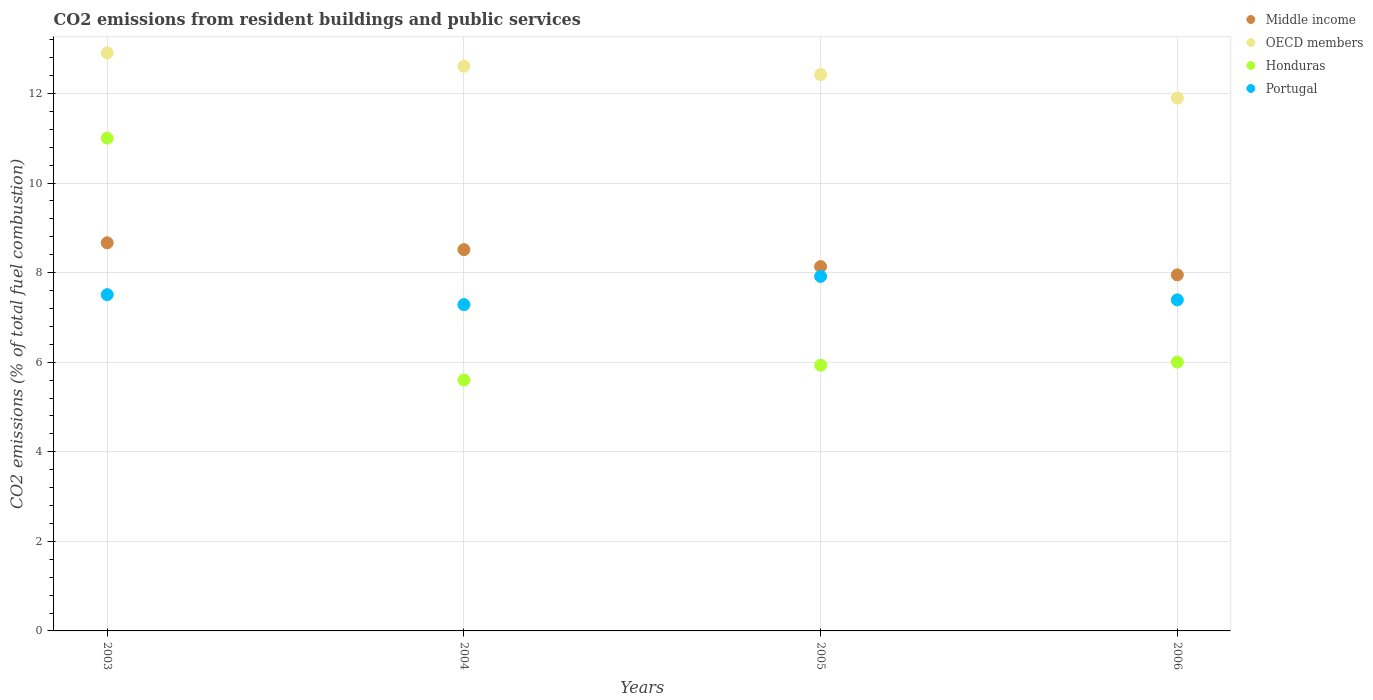How many different coloured dotlines are there?
Give a very brief answer. 4. What is the total CO2 emitted in OECD members in 2005?
Keep it short and to the point. 12.42. Across all years, what is the maximum total CO2 emitted in OECD members?
Provide a succinct answer. 12.91. Across all years, what is the minimum total CO2 emitted in Middle income?
Provide a short and direct response. 7.95. In which year was the total CO2 emitted in Honduras minimum?
Ensure brevity in your answer.  2004. What is the total total CO2 emitted in Portugal in the graph?
Offer a very short reply. 30.1. What is the difference between the total CO2 emitted in Portugal in 2003 and that in 2004?
Give a very brief answer. 0.22. What is the difference between the total CO2 emitted in Middle income in 2004 and the total CO2 emitted in OECD members in 2005?
Make the answer very short. -3.91. What is the average total CO2 emitted in Honduras per year?
Offer a terse response. 7.14. In the year 2005, what is the difference between the total CO2 emitted in Portugal and total CO2 emitted in Honduras?
Offer a very short reply. 1.98. What is the ratio of the total CO2 emitted in Middle income in 2003 to that in 2004?
Keep it short and to the point. 1.02. What is the difference between the highest and the second highest total CO2 emitted in Honduras?
Your answer should be compact. 5. What is the difference between the highest and the lowest total CO2 emitted in OECD members?
Keep it short and to the point. 1.01. In how many years, is the total CO2 emitted in Portugal greater than the average total CO2 emitted in Portugal taken over all years?
Provide a short and direct response. 1. Is it the case that in every year, the sum of the total CO2 emitted in Honduras and total CO2 emitted in OECD members  is greater than the sum of total CO2 emitted in Portugal and total CO2 emitted in Middle income?
Your answer should be very brief. Yes. Is the total CO2 emitted in Middle income strictly less than the total CO2 emitted in Honduras over the years?
Offer a very short reply. No. How many years are there in the graph?
Offer a very short reply. 4. Are the values on the major ticks of Y-axis written in scientific E-notation?
Your response must be concise. No. Does the graph contain grids?
Make the answer very short. Yes. How many legend labels are there?
Ensure brevity in your answer.  4. How are the legend labels stacked?
Your answer should be very brief. Vertical. What is the title of the graph?
Provide a short and direct response. CO2 emissions from resident buildings and public services. What is the label or title of the Y-axis?
Ensure brevity in your answer.  CO2 emissions (% of total fuel combustion). What is the CO2 emissions (% of total fuel combustion) of Middle income in 2003?
Ensure brevity in your answer.  8.67. What is the CO2 emissions (% of total fuel combustion) in OECD members in 2003?
Make the answer very short. 12.91. What is the CO2 emissions (% of total fuel combustion) in Honduras in 2003?
Offer a very short reply. 11. What is the CO2 emissions (% of total fuel combustion) in Portugal in 2003?
Your answer should be compact. 7.51. What is the CO2 emissions (% of total fuel combustion) in Middle income in 2004?
Make the answer very short. 8.51. What is the CO2 emissions (% of total fuel combustion) of OECD members in 2004?
Make the answer very short. 12.61. What is the CO2 emissions (% of total fuel combustion) in Honduras in 2004?
Provide a short and direct response. 5.6. What is the CO2 emissions (% of total fuel combustion) of Portugal in 2004?
Your answer should be very brief. 7.29. What is the CO2 emissions (% of total fuel combustion) of Middle income in 2005?
Offer a very short reply. 8.13. What is the CO2 emissions (% of total fuel combustion) of OECD members in 2005?
Your response must be concise. 12.42. What is the CO2 emissions (% of total fuel combustion) of Honduras in 2005?
Your answer should be very brief. 5.93. What is the CO2 emissions (% of total fuel combustion) of Portugal in 2005?
Your answer should be compact. 7.92. What is the CO2 emissions (% of total fuel combustion) of Middle income in 2006?
Ensure brevity in your answer.  7.95. What is the CO2 emissions (% of total fuel combustion) of OECD members in 2006?
Your answer should be compact. 11.9. What is the CO2 emissions (% of total fuel combustion) of Honduras in 2006?
Make the answer very short. 6. What is the CO2 emissions (% of total fuel combustion) of Portugal in 2006?
Your response must be concise. 7.39. Across all years, what is the maximum CO2 emissions (% of total fuel combustion) of Middle income?
Make the answer very short. 8.67. Across all years, what is the maximum CO2 emissions (% of total fuel combustion) of OECD members?
Your response must be concise. 12.91. Across all years, what is the maximum CO2 emissions (% of total fuel combustion) in Honduras?
Give a very brief answer. 11. Across all years, what is the maximum CO2 emissions (% of total fuel combustion) in Portugal?
Provide a short and direct response. 7.92. Across all years, what is the minimum CO2 emissions (% of total fuel combustion) of Middle income?
Keep it short and to the point. 7.95. Across all years, what is the minimum CO2 emissions (% of total fuel combustion) of OECD members?
Your answer should be very brief. 11.9. Across all years, what is the minimum CO2 emissions (% of total fuel combustion) of Honduras?
Make the answer very short. 5.6. Across all years, what is the minimum CO2 emissions (% of total fuel combustion) of Portugal?
Offer a very short reply. 7.29. What is the total CO2 emissions (% of total fuel combustion) of Middle income in the graph?
Provide a succinct answer. 33.27. What is the total CO2 emissions (% of total fuel combustion) in OECD members in the graph?
Your answer should be very brief. 49.84. What is the total CO2 emissions (% of total fuel combustion) in Honduras in the graph?
Make the answer very short. 28.54. What is the total CO2 emissions (% of total fuel combustion) in Portugal in the graph?
Offer a very short reply. 30.1. What is the difference between the CO2 emissions (% of total fuel combustion) in Middle income in 2003 and that in 2004?
Provide a short and direct response. 0.15. What is the difference between the CO2 emissions (% of total fuel combustion) in OECD members in 2003 and that in 2004?
Your answer should be compact. 0.3. What is the difference between the CO2 emissions (% of total fuel combustion) in Honduras in 2003 and that in 2004?
Ensure brevity in your answer.  5.4. What is the difference between the CO2 emissions (% of total fuel combustion) in Portugal in 2003 and that in 2004?
Give a very brief answer. 0.22. What is the difference between the CO2 emissions (% of total fuel combustion) in Middle income in 2003 and that in 2005?
Provide a short and direct response. 0.53. What is the difference between the CO2 emissions (% of total fuel combustion) in OECD members in 2003 and that in 2005?
Ensure brevity in your answer.  0.48. What is the difference between the CO2 emissions (% of total fuel combustion) in Honduras in 2003 and that in 2005?
Make the answer very short. 5.07. What is the difference between the CO2 emissions (% of total fuel combustion) in Portugal in 2003 and that in 2005?
Your answer should be compact. -0.41. What is the difference between the CO2 emissions (% of total fuel combustion) in Middle income in 2003 and that in 2006?
Your answer should be compact. 0.72. What is the difference between the CO2 emissions (% of total fuel combustion) in OECD members in 2003 and that in 2006?
Your answer should be compact. 1.01. What is the difference between the CO2 emissions (% of total fuel combustion) in Honduras in 2003 and that in 2006?
Offer a terse response. 5. What is the difference between the CO2 emissions (% of total fuel combustion) of Portugal in 2003 and that in 2006?
Give a very brief answer. 0.12. What is the difference between the CO2 emissions (% of total fuel combustion) of Middle income in 2004 and that in 2005?
Provide a short and direct response. 0.38. What is the difference between the CO2 emissions (% of total fuel combustion) in OECD members in 2004 and that in 2005?
Provide a short and direct response. 0.19. What is the difference between the CO2 emissions (% of total fuel combustion) of Honduras in 2004 and that in 2005?
Your answer should be compact. -0.33. What is the difference between the CO2 emissions (% of total fuel combustion) in Portugal in 2004 and that in 2005?
Your response must be concise. -0.63. What is the difference between the CO2 emissions (% of total fuel combustion) of Middle income in 2004 and that in 2006?
Provide a succinct answer. 0.56. What is the difference between the CO2 emissions (% of total fuel combustion) of OECD members in 2004 and that in 2006?
Make the answer very short. 0.71. What is the difference between the CO2 emissions (% of total fuel combustion) of Honduras in 2004 and that in 2006?
Provide a short and direct response. -0.4. What is the difference between the CO2 emissions (% of total fuel combustion) of Portugal in 2004 and that in 2006?
Your response must be concise. -0.11. What is the difference between the CO2 emissions (% of total fuel combustion) in Middle income in 2005 and that in 2006?
Keep it short and to the point. 0.18. What is the difference between the CO2 emissions (% of total fuel combustion) in OECD members in 2005 and that in 2006?
Your answer should be very brief. 0.52. What is the difference between the CO2 emissions (% of total fuel combustion) of Honduras in 2005 and that in 2006?
Keep it short and to the point. -0.07. What is the difference between the CO2 emissions (% of total fuel combustion) of Portugal in 2005 and that in 2006?
Your answer should be very brief. 0.52. What is the difference between the CO2 emissions (% of total fuel combustion) of Middle income in 2003 and the CO2 emissions (% of total fuel combustion) of OECD members in 2004?
Keep it short and to the point. -3.94. What is the difference between the CO2 emissions (% of total fuel combustion) in Middle income in 2003 and the CO2 emissions (% of total fuel combustion) in Honduras in 2004?
Give a very brief answer. 3.06. What is the difference between the CO2 emissions (% of total fuel combustion) of Middle income in 2003 and the CO2 emissions (% of total fuel combustion) of Portugal in 2004?
Your answer should be very brief. 1.38. What is the difference between the CO2 emissions (% of total fuel combustion) of OECD members in 2003 and the CO2 emissions (% of total fuel combustion) of Honduras in 2004?
Your response must be concise. 7.3. What is the difference between the CO2 emissions (% of total fuel combustion) of OECD members in 2003 and the CO2 emissions (% of total fuel combustion) of Portugal in 2004?
Provide a succinct answer. 5.62. What is the difference between the CO2 emissions (% of total fuel combustion) of Honduras in 2003 and the CO2 emissions (% of total fuel combustion) of Portugal in 2004?
Your answer should be very brief. 3.72. What is the difference between the CO2 emissions (% of total fuel combustion) of Middle income in 2003 and the CO2 emissions (% of total fuel combustion) of OECD members in 2005?
Give a very brief answer. -3.76. What is the difference between the CO2 emissions (% of total fuel combustion) in Middle income in 2003 and the CO2 emissions (% of total fuel combustion) in Honduras in 2005?
Provide a short and direct response. 2.73. What is the difference between the CO2 emissions (% of total fuel combustion) of Middle income in 2003 and the CO2 emissions (% of total fuel combustion) of Portugal in 2005?
Provide a succinct answer. 0.75. What is the difference between the CO2 emissions (% of total fuel combustion) of OECD members in 2003 and the CO2 emissions (% of total fuel combustion) of Honduras in 2005?
Your answer should be compact. 6.97. What is the difference between the CO2 emissions (% of total fuel combustion) in OECD members in 2003 and the CO2 emissions (% of total fuel combustion) in Portugal in 2005?
Give a very brief answer. 4.99. What is the difference between the CO2 emissions (% of total fuel combustion) in Honduras in 2003 and the CO2 emissions (% of total fuel combustion) in Portugal in 2005?
Your response must be concise. 3.09. What is the difference between the CO2 emissions (% of total fuel combustion) in Middle income in 2003 and the CO2 emissions (% of total fuel combustion) in OECD members in 2006?
Offer a terse response. -3.23. What is the difference between the CO2 emissions (% of total fuel combustion) in Middle income in 2003 and the CO2 emissions (% of total fuel combustion) in Honduras in 2006?
Ensure brevity in your answer.  2.66. What is the difference between the CO2 emissions (% of total fuel combustion) in Middle income in 2003 and the CO2 emissions (% of total fuel combustion) in Portugal in 2006?
Offer a terse response. 1.27. What is the difference between the CO2 emissions (% of total fuel combustion) of OECD members in 2003 and the CO2 emissions (% of total fuel combustion) of Honduras in 2006?
Your answer should be very brief. 6.9. What is the difference between the CO2 emissions (% of total fuel combustion) in OECD members in 2003 and the CO2 emissions (% of total fuel combustion) in Portugal in 2006?
Keep it short and to the point. 5.51. What is the difference between the CO2 emissions (% of total fuel combustion) of Honduras in 2003 and the CO2 emissions (% of total fuel combustion) of Portugal in 2006?
Your response must be concise. 3.61. What is the difference between the CO2 emissions (% of total fuel combustion) in Middle income in 2004 and the CO2 emissions (% of total fuel combustion) in OECD members in 2005?
Your response must be concise. -3.91. What is the difference between the CO2 emissions (% of total fuel combustion) in Middle income in 2004 and the CO2 emissions (% of total fuel combustion) in Honduras in 2005?
Offer a very short reply. 2.58. What is the difference between the CO2 emissions (% of total fuel combustion) in Middle income in 2004 and the CO2 emissions (% of total fuel combustion) in Portugal in 2005?
Offer a very short reply. 0.6. What is the difference between the CO2 emissions (% of total fuel combustion) in OECD members in 2004 and the CO2 emissions (% of total fuel combustion) in Honduras in 2005?
Offer a very short reply. 6.68. What is the difference between the CO2 emissions (% of total fuel combustion) in OECD members in 2004 and the CO2 emissions (% of total fuel combustion) in Portugal in 2005?
Provide a short and direct response. 4.69. What is the difference between the CO2 emissions (% of total fuel combustion) in Honduras in 2004 and the CO2 emissions (% of total fuel combustion) in Portugal in 2005?
Give a very brief answer. -2.31. What is the difference between the CO2 emissions (% of total fuel combustion) in Middle income in 2004 and the CO2 emissions (% of total fuel combustion) in OECD members in 2006?
Your response must be concise. -3.38. What is the difference between the CO2 emissions (% of total fuel combustion) in Middle income in 2004 and the CO2 emissions (% of total fuel combustion) in Honduras in 2006?
Your answer should be compact. 2.51. What is the difference between the CO2 emissions (% of total fuel combustion) in Middle income in 2004 and the CO2 emissions (% of total fuel combustion) in Portugal in 2006?
Make the answer very short. 1.12. What is the difference between the CO2 emissions (% of total fuel combustion) in OECD members in 2004 and the CO2 emissions (% of total fuel combustion) in Honduras in 2006?
Give a very brief answer. 6.61. What is the difference between the CO2 emissions (% of total fuel combustion) of OECD members in 2004 and the CO2 emissions (% of total fuel combustion) of Portugal in 2006?
Make the answer very short. 5.22. What is the difference between the CO2 emissions (% of total fuel combustion) of Honduras in 2004 and the CO2 emissions (% of total fuel combustion) of Portugal in 2006?
Offer a terse response. -1.79. What is the difference between the CO2 emissions (% of total fuel combustion) of Middle income in 2005 and the CO2 emissions (% of total fuel combustion) of OECD members in 2006?
Make the answer very short. -3.76. What is the difference between the CO2 emissions (% of total fuel combustion) in Middle income in 2005 and the CO2 emissions (% of total fuel combustion) in Honduras in 2006?
Provide a succinct answer. 2.13. What is the difference between the CO2 emissions (% of total fuel combustion) in Middle income in 2005 and the CO2 emissions (% of total fuel combustion) in Portugal in 2006?
Give a very brief answer. 0.74. What is the difference between the CO2 emissions (% of total fuel combustion) of OECD members in 2005 and the CO2 emissions (% of total fuel combustion) of Honduras in 2006?
Your answer should be compact. 6.42. What is the difference between the CO2 emissions (% of total fuel combustion) in OECD members in 2005 and the CO2 emissions (% of total fuel combustion) in Portugal in 2006?
Make the answer very short. 5.03. What is the difference between the CO2 emissions (% of total fuel combustion) in Honduras in 2005 and the CO2 emissions (% of total fuel combustion) in Portugal in 2006?
Keep it short and to the point. -1.46. What is the average CO2 emissions (% of total fuel combustion) in Middle income per year?
Give a very brief answer. 8.32. What is the average CO2 emissions (% of total fuel combustion) of OECD members per year?
Your response must be concise. 12.46. What is the average CO2 emissions (% of total fuel combustion) in Honduras per year?
Offer a terse response. 7.14. What is the average CO2 emissions (% of total fuel combustion) of Portugal per year?
Ensure brevity in your answer.  7.53. In the year 2003, what is the difference between the CO2 emissions (% of total fuel combustion) of Middle income and CO2 emissions (% of total fuel combustion) of OECD members?
Offer a very short reply. -4.24. In the year 2003, what is the difference between the CO2 emissions (% of total fuel combustion) of Middle income and CO2 emissions (% of total fuel combustion) of Honduras?
Your answer should be compact. -2.34. In the year 2003, what is the difference between the CO2 emissions (% of total fuel combustion) in Middle income and CO2 emissions (% of total fuel combustion) in Portugal?
Your answer should be very brief. 1.16. In the year 2003, what is the difference between the CO2 emissions (% of total fuel combustion) in OECD members and CO2 emissions (% of total fuel combustion) in Honduras?
Offer a terse response. 1.9. In the year 2003, what is the difference between the CO2 emissions (% of total fuel combustion) of OECD members and CO2 emissions (% of total fuel combustion) of Portugal?
Offer a very short reply. 5.4. In the year 2003, what is the difference between the CO2 emissions (% of total fuel combustion) of Honduras and CO2 emissions (% of total fuel combustion) of Portugal?
Provide a succinct answer. 3.49. In the year 2004, what is the difference between the CO2 emissions (% of total fuel combustion) of Middle income and CO2 emissions (% of total fuel combustion) of OECD members?
Give a very brief answer. -4.09. In the year 2004, what is the difference between the CO2 emissions (% of total fuel combustion) in Middle income and CO2 emissions (% of total fuel combustion) in Honduras?
Give a very brief answer. 2.91. In the year 2004, what is the difference between the CO2 emissions (% of total fuel combustion) in Middle income and CO2 emissions (% of total fuel combustion) in Portugal?
Your answer should be very brief. 1.23. In the year 2004, what is the difference between the CO2 emissions (% of total fuel combustion) of OECD members and CO2 emissions (% of total fuel combustion) of Honduras?
Your response must be concise. 7.01. In the year 2004, what is the difference between the CO2 emissions (% of total fuel combustion) of OECD members and CO2 emissions (% of total fuel combustion) of Portugal?
Give a very brief answer. 5.32. In the year 2004, what is the difference between the CO2 emissions (% of total fuel combustion) of Honduras and CO2 emissions (% of total fuel combustion) of Portugal?
Your answer should be compact. -1.68. In the year 2005, what is the difference between the CO2 emissions (% of total fuel combustion) in Middle income and CO2 emissions (% of total fuel combustion) in OECD members?
Your answer should be compact. -4.29. In the year 2005, what is the difference between the CO2 emissions (% of total fuel combustion) in Middle income and CO2 emissions (% of total fuel combustion) in Honduras?
Offer a terse response. 2.2. In the year 2005, what is the difference between the CO2 emissions (% of total fuel combustion) in Middle income and CO2 emissions (% of total fuel combustion) in Portugal?
Provide a succinct answer. 0.22. In the year 2005, what is the difference between the CO2 emissions (% of total fuel combustion) of OECD members and CO2 emissions (% of total fuel combustion) of Honduras?
Offer a terse response. 6.49. In the year 2005, what is the difference between the CO2 emissions (% of total fuel combustion) of OECD members and CO2 emissions (% of total fuel combustion) of Portugal?
Provide a short and direct response. 4.51. In the year 2005, what is the difference between the CO2 emissions (% of total fuel combustion) in Honduras and CO2 emissions (% of total fuel combustion) in Portugal?
Make the answer very short. -1.98. In the year 2006, what is the difference between the CO2 emissions (% of total fuel combustion) in Middle income and CO2 emissions (% of total fuel combustion) in OECD members?
Your answer should be compact. -3.95. In the year 2006, what is the difference between the CO2 emissions (% of total fuel combustion) in Middle income and CO2 emissions (% of total fuel combustion) in Honduras?
Provide a succinct answer. 1.95. In the year 2006, what is the difference between the CO2 emissions (% of total fuel combustion) of Middle income and CO2 emissions (% of total fuel combustion) of Portugal?
Offer a very short reply. 0.56. In the year 2006, what is the difference between the CO2 emissions (% of total fuel combustion) of OECD members and CO2 emissions (% of total fuel combustion) of Honduras?
Give a very brief answer. 5.9. In the year 2006, what is the difference between the CO2 emissions (% of total fuel combustion) in OECD members and CO2 emissions (% of total fuel combustion) in Portugal?
Make the answer very short. 4.51. In the year 2006, what is the difference between the CO2 emissions (% of total fuel combustion) in Honduras and CO2 emissions (% of total fuel combustion) in Portugal?
Offer a very short reply. -1.39. What is the ratio of the CO2 emissions (% of total fuel combustion) in Middle income in 2003 to that in 2004?
Your answer should be compact. 1.02. What is the ratio of the CO2 emissions (% of total fuel combustion) in OECD members in 2003 to that in 2004?
Offer a very short reply. 1.02. What is the ratio of the CO2 emissions (% of total fuel combustion) of Honduras in 2003 to that in 2004?
Ensure brevity in your answer.  1.96. What is the ratio of the CO2 emissions (% of total fuel combustion) in Portugal in 2003 to that in 2004?
Offer a terse response. 1.03. What is the ratio of the CO2 emissions (% of total fuel combustion) of Middle income in 2003 to that in 2005?
Offer a very short reply. 1.07. What is the ratio of the CO2 emissions (% of total fuel combustion) in OECD members in 2003 to that in 2005?
Offer a very short reply. 1.04. What is the ratio of the CO2 emissions (% of total fuel combustion) in Honduras in 2003 to that in 2005?
Your answer should be compact. 1.85. What is the ratio of the CO2 emissions (% of total fuel combustion) in Portugal in 2003 to that in 2005?
Give a very brief answer. 0.95. What is the ratio of the CO2 emissions (% of total fuel combustion) of Middle income in 2003 to that in 2006?
Your answer should be compact. 1.09. What is the ratio of the CO2 emissions (% of total fuel combustion) of OECD members in 2003 to that in 2006?
Make the answer very short. 1.08. What is the ratio of the CO2 emissions (% of total fuel combustion) in Honduras in 2003 to that in 2006?
Your answer should be very brief. 1.83. What is the ratio of the CO2 emissions (% of total fuel combustion) of Portugal in 2003 to that in 2006?
Ensure brevity in your answer.  1.02. What is the ratio of the CO2 emissions (% of total fuel combustion) in Middle income in 2004 to that in 2005?
Your answer should be compact. 1.05. What is the ratio of the CO2 emissions (% of total fuel combustion) in OECD members in 2004 to that in 2005?
Ensure brevity in your answer.  1.01. What is the ratio of the CO2 emissions (% of total fuel combustion) of Honduras in 2004 to that in 2005?
Provide a succinct answer. 0.94. What is the ratio of the CO2 emissions (% of total fuel combustion) of Portugal in 2004 to that in 2005?
Make the answer very short. 0.92. What is the ratio of the CO2 emissions (% of total fuel combustion) of Middle income in 2004 to that in 2006?
Make the answer very short. 1.07. What is the ratio of the CO2 emissions (% of total fuel combustion) of OECD members in 2004 to that in 2006?
Offer a terse response. 1.06. What is the ratio of the CO2 emissions (% of total fuel combustion) in Honduras in 2004 to that in 2006?
Offer a very short reply. 0.93. What is the ratio of the CO2 emissions (% of total fuel combustion) of Portugal in 2004 to that in 2006?
Give a very brief answer. 0.99. What is the ratio of the CO2 emissions (% of total fuel combustion) of Middle income in 2005 to that in 2006?
Offer a very short reply. 1.02. What is the ratio of the CO2 emissions (% of total fuel combustion) in OECD members in 2005 to that in 2006?
Your answer should be very brief. 1.04. What is the ratio of the CO2 emissions (% of total fuel combustion) of Portugal in 2005 to that in 2006?
Your response must be concise. 1.07. What is the difference between the highest and the second highest CO2 emissions (% of total fuel combustion) in Middle income?
Provide a short and direct response. 0.15. What is the difference between the highest and the second highest CO2 emissions (% of total fuel combustion) in OECD members?
Offer a very short reply. 0.3. What is the difference between the highest and the second highest CO2 emissions (% of total fuel combustion) of Honduras?
Make the answer very short. 5. What is the difference between the highest and the second highest CO2 emissions (% of total fuel combustion) in Portugal?
Your answer should be very brief. 0.41. What is the difference between the highest and the lowest CO2 emissions (% of total fuel combustion) in Middle income?
Your response must be concise. 0.72. What is the difference between the highest and the lowest CO2 emissions (% of total fuel combustion) of OECD members?
Provide a succinct answer. 1.01. What is the difference between the highest and the lowest CO2 emissions (% of total fuel combustion) of Honduras?
Make the answer very short. 5.4. What is the difference between the highest and the lowest CO2 emissions (% of total fuel combustion) in Portugal?
Your answer should be very brief. 0.63. 